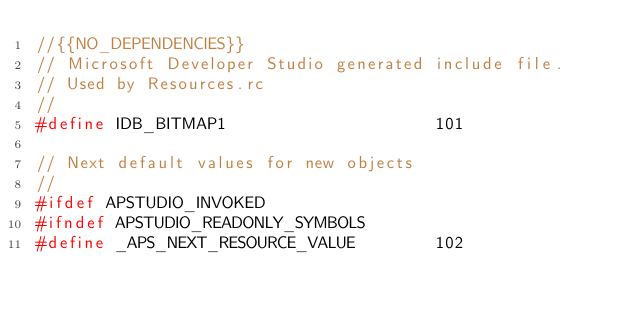<code> <loc_0><loc_0><loc_500><loc_500><_C_>//{{NO_DEPENDENCIES}}
// Microsoft Developer Studio generated include file.
// Used by Resources.rc
//
#define IDB_BITMAP1                     101

// Next default values for new objects
// 
#ifdef APSTUDIO_INVOKED
#ifndef APSTUDIO_READONLY_SYMBOLS
#define _APS_NEXT_RESOURCE_VALUE        102</code> 